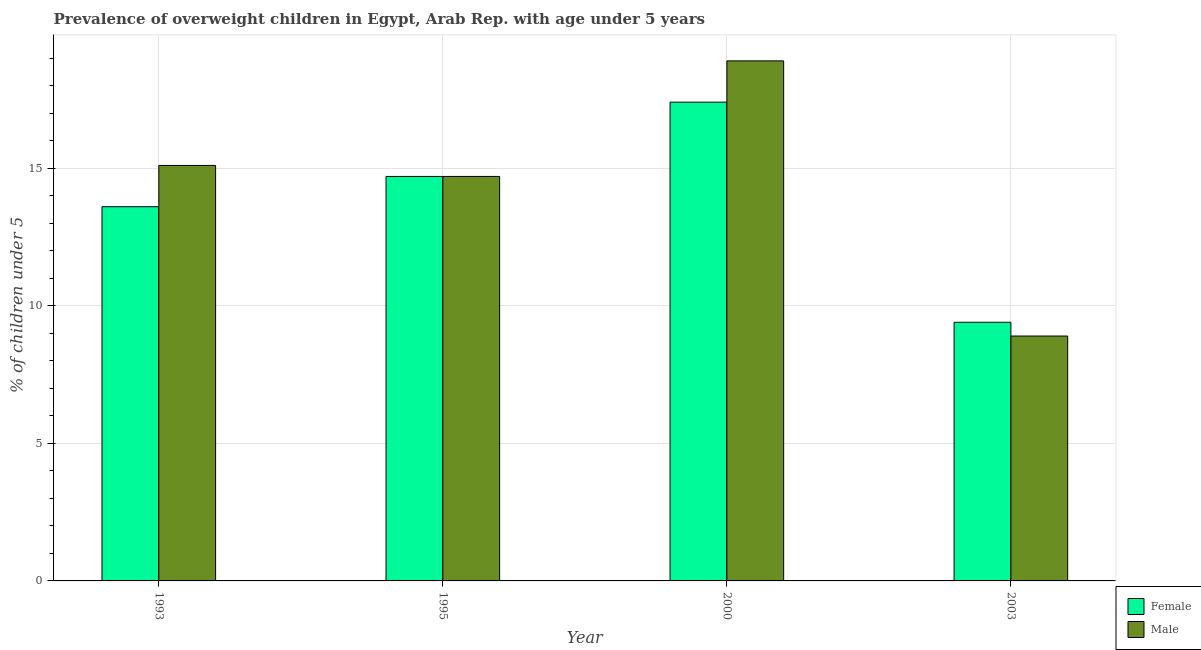How many different coloured bars are there?
Offer a terse response. 2. How many groups of bars are there?
Offer a terse response. 4. Are the number of bars on each tick of the X-axis equal?
Make the answer very short. Yes. How many bars are there on the 3rd tick from the left?
Provide a succinct answer. 2. In how many cases, is the number of bars for a given year not equal to the number of legend labels?
Make the answer very short. 0. What is the percentage of obese female children in 1993?
Provide a succinct answer. 13.6. Across all years, what is the maximum percentage of obese male children?
Make the answer very short. 18.9. Across all years, what is the minimum percentage of obese male children?
Ensure brevity in your answer.  8.9. In which year was the percentage of obese female children maximum?
Your answer should be very brief. 2000. In which year was the percentage of obese female children minimum?
Keep it short and to the point. 2003. What is the total percentage of obese male children in the graph?
Keep it short and to the point. 57.6. What is the difference between the percentage of obese male children in 1993 and that in 2003?
Your answer should be compact. 6.2. What is the difference between the percentage of obese female children in 1995 and the percentage of obese male children in 1993?
Your answer should be compact. 1.1. What is the average percentage of obese male children per year?
Provide a succinct answer. 14.4. What is the ratio of the percentage of obese male children in 2000 to that in 2003?
Provide a short and direct response. 2.12. What is the difference between the highest and the second highest percentage of obese female children?
Keep it short and to the point. 2.7. What is the difference between the highest and the lowest percentage of obese female children?
Offer a very short reply. 8. In how many years, is the percentage of obese male children greater than the average percentage of obese male children taken over all years?
Make the answer very short. 3. What does the 1st bar from the right in 2000 represents?
Provide a short and direct response. Male. Are the values on the major ticks of Y-axis written in scientific E-notation?
Your answer should be compact. No. Does the graph contain grids?
Provide a short and direct response. Yes. What is the title of the graph?
Your response must be concise. Prevalence of overweight children in Egypt, Arab Rep. with age under 5 years. Does "Measles" appear as one of the legend labels in the graph?
Provide a succinct answer. No. What is the label or title of the Y-axis?
Your response must be concise.  % of children under 5. What is the  % of children under 5 of Female in 1993?
Your response must be concise. 13.6. What is the  % of children under 5 of Male in 1993?
Your response must be concise. 15.1. What is the  % of children under 5 in Female in 1995?
Your answer should be very brief. 14.7. What is the  % of children under 5 of Male in 1995?
Give a very brief answer. 14.7. What is the  % of children under 5 of Female in 2000?
Make the answer very short. 17.4. What is the  % of children under 5 in Male in 2000?
Your response must be concise. 18.9. What is the  % of children under 5 of Female in 2003?
Keep it short and to the point. 9.4. What is the  % of children under 5 of Male in 2003?
Offer a terse response. 8.9. Across all years, what is the maximum  % of children under 5 of Female?
Give a very brief answer. 17.4. Across all years, what is the maximum  % of children under 5 of Male?
Provide a short and direct response. 18.9. Across all years, what is the minimum  % of children under 5 in Female?
Provide a succinct answer. 9.4. Across all years, what is the minimum  % of children under 5 in Male?
Your answer should be compact. 8.9. What is the total  % of children under 5 of Female in the graph?
Your answer should be very brief. 55.1. What is the total  % of children under 5 of Male in the graph?
Make the answer very short. 57.6. What is the difference between the  % of children under 5 of Female in 1993 and that in 2000?
Your answer should be compact. -3.8. What is the difference between the  % of children under 5 in Male in 1993 and that in 2000?
Offer a very short reply. -3.8. What is the difference between the  % of children under 5 of Female in 1993 and that in 2003?
Provide a succinct answer. 4.2. What is the difference between the  % of children under 5 of Female in 1995 and that in 2000?
Offer a terse response. -2.7. What is the difference between the  % of children under 5 in Male in 1995 and that in 2000?
Provide a succinct answer. -4.2. What is the difference between the  % of children under 5 of Male in 1995 and that in 2003?
Your answer should be very brief. 5.8. What is the difference between the  % of children under 5 of Female in 2000 and that in 2003?
Keep it short and to the point. 8. What is the difference between the  % of children under 5 of Male in 2000 and that in 2003?
Ensure brevity in your answer.  10. What is the difference between the  % of children under 5 in Female in 1993 and the  % of children under 5 in Male in 1995?
Provide a succinct answer. -1.1. What is the difference between the  % of children under 5 of Female in 1993 and the  % of children under 5 of Male in 2003?
Your response must be concise. 4.7. What is the difference between the  % of children under 5 in Female in 1995 and the  % of children under 5 in Male in 2000?
Offer a terse response. -4.2. What is the difference between the  % of children under 5 of Female in 1995 and the  % of children under 5 of Male in 2003?
Your response must be concise. 5.8. What is the average  % of children under 5 of Female per year?
Make the answer very short. 13.78. What is the average  % of children under 5 of Male per year?
Provide a short and direct response. 14.4. In the year 1995, what is the difference between the  % of children under 5 in Female and  % of children under 5 in Male?
Offer a terse response. 0. In the year 2003, what is the difference between the  % of children under 5 in Female and  % of children under 5 in Male?
Make the answer very short. 0.5. What is the ratio of the  % of children under 5 of Female in 1993 to that in 1995?
Offer a very short reply. 0.93. What is the ratio of the  % of children under 5 in Male in 1993 to that in 1995?
Your answer should be compact. 1.03. What is the ratio of the  % of children under 5 of Female in 1993 to that in 2000?
Your answer should be very brief. 0.78. What is the ratio of the  % of children under 5 of Male in 1993 to that in 2000?
Give a very brief answer. 0.8. What is the ratio of the  % of children under 5 in Female in 1993 to that in 2003?
Make the answer very short. 1.45. What is the ratio of the  % of children under 5 of Male in 1993 to that in 2003?
Offer a terse response. 1.7. What is the ratio of the  % of children under 5 of Female in 1995 to that in 2000?
Offer a very short reply. 0.84. What is the ratio of the  % of children under 5 of Female in 1995 to that in 2003?
Ensure brevity in your answer.  1.56. What is the ratio of the  % of children under 5 of Male in 1995 to that in 2003?
Give a very brief answer. 1.65. What is the ratio of the  % of children under 5 in Female in 2000 to that in 2003?
Offer a terse response. 1.85. What is the ratio of the  % of children under 5 in Male in 2000 to that in 2003?
Offer a very short reply. 2.12. What is the difference between the highest and the second highest  % of children under 5 in Female?
Your answer should be compact. 2.7. What is the difference between the highest and the second highest  % of children under 5 of Male?
Offer a very short reply. 3.8. What is the difference between the highest and the lowest  % of children under 5 in Female?
Your response must be concise. 8. What is the difference between the highest and the lowest  % of children under 5 in Male?
Give a very brief answer. 10. 